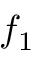<formula> <loc_0><loc_0><loc_500><loc_500>f _ { 1 }</formula> 